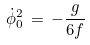Convert formula to latex. <formula><loc_0><loc_0><loc_500><loc_500>\dot { \phi } _ { 0 } ^ { 2 } \, = \, - \frac { g } { 6 f }</formula> 